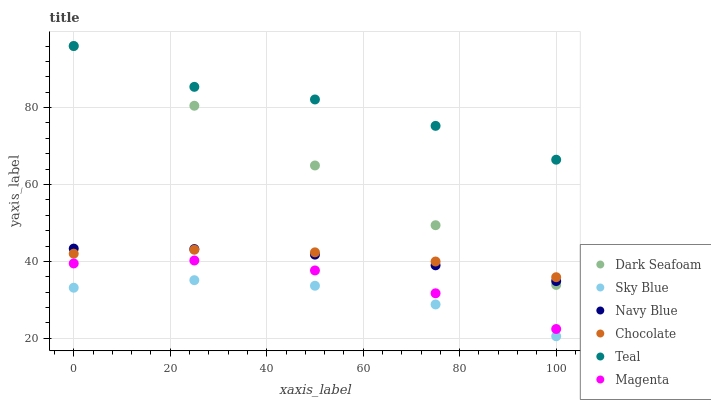Does Sky Blue have the minimum area under the curve?
Answer yes or no. Yes. Does Teal have the maximum area under the curve?
Answer yes or no. Yes. Does Chocolate have the minimum area under the curve?
Answer yes or no. No. Does Chocolate have the maximum area under the curve?
Answer yes or no. No. Is Dark Seafoam the smoothest?
Answer yes or no. Yes. Is Teal the roughest?
Answer yes or no. Yes. Is Chocolate the smoothest?
Answer yes or no. No. Is Chocolate the roughest?
Answer yes or no. No. Does Sky Blue have the lowest value?
Answer yes or no. Yes. Does Chocolate have the lowest value?
Answer yes or no. No. Does Teal have the highest value?
Answer yes or no. Yes. Does Chocolate have the highest value?
Answer yes or no. No. Is Chocolate less than Teal?
Answer yes or no. Yes. Is Teal greater than Sky Blue?
Answer yes or no. Yes. Does Teal intersect Dark Seafoam?
Answer yes or no. Yes. Is Teal less than Dark Seafoam?
Answer yes or no. No. Is Teal greater than Dark Seafoam?
Answer yes or no. No. Does Chocolate intersect Teal?
Answer yes or no. No. 